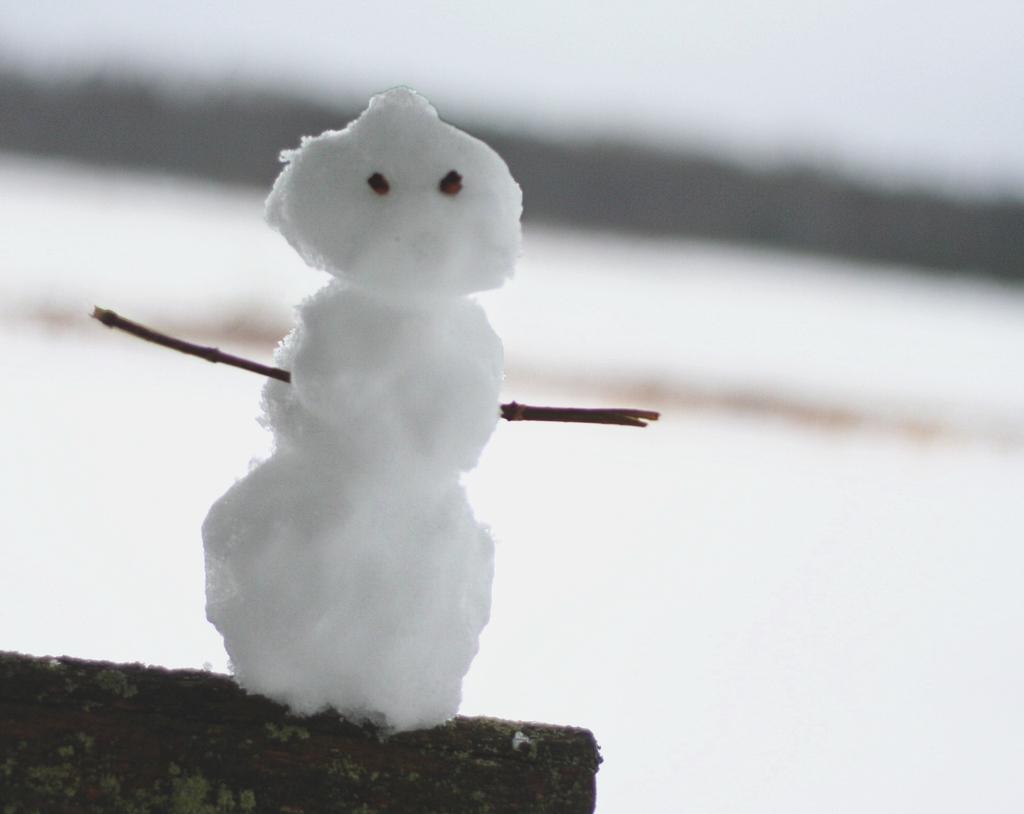Describe this image in one or two sentences. In this image we can see a snowman and in the background, the image is blurred. 